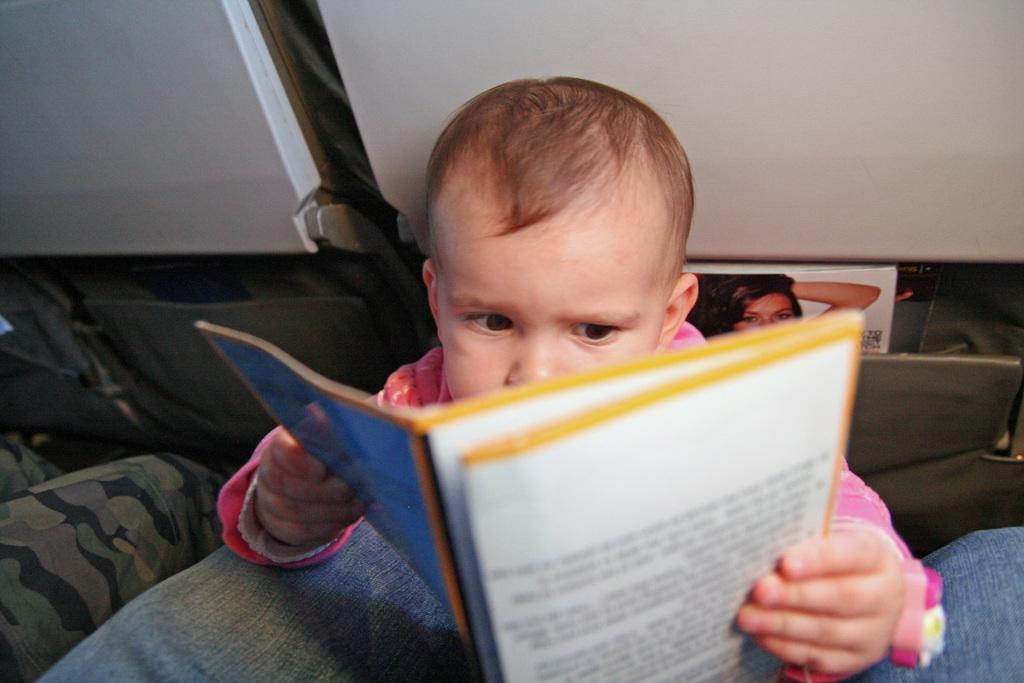How would you summarize this image in a sentence or two? In the middle of this image there is a baby holding a book in the hands and looking into the book. At the bottom, I can see two persons legs. At the back of this baby there are two seats and there is a poster on which I can see an image of a woman. 